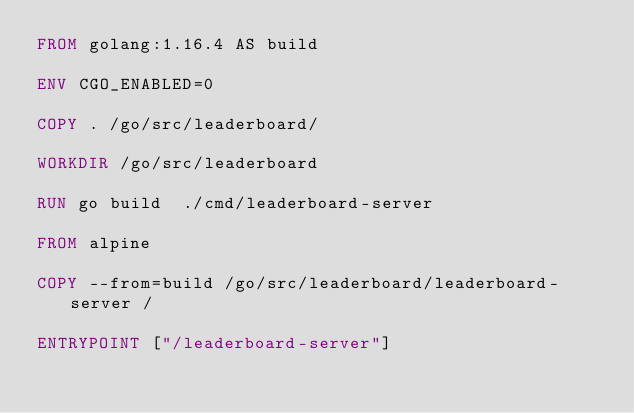Convert code to text. <code><loc_0><loc_0><loc_500><loc_500><_Dockerfile_>FROM golang:1.16.4 AS build

ENV CGO_ENABLED=0

COPY . /go/src/leaderboard/

WORKDIR /go/src/leaderboard

RUN go build  ./cmd/leaderboard-server

FROM alpine

COPY --from=build /go/src/leaderboard/leaderboard-server /

ENTRYPOINT ["/leaderboard-server"]
</code> 